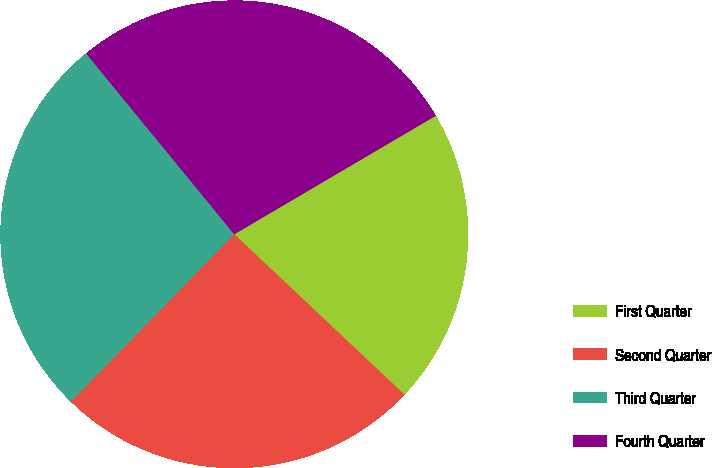<chart> <loc_0><loc_0><loc_500><loc_500><pie_chart><fcel>First Quarter<fcel>Second Quarter<fcel>Third Quarter<fcel>Fourth Quarter<nl><fcel>20.49%<fcel>25.28%<fcel>26.77%<fcel>27.46%<nl></chart> 